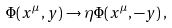<formula> <loc_0><loc_0><loc_500><loc_500>\Phi ( x ^ { \mu } , y ) \rightarrow \eta \Phi ( x ^ { \mu } , - y ) \, ,</formula> 